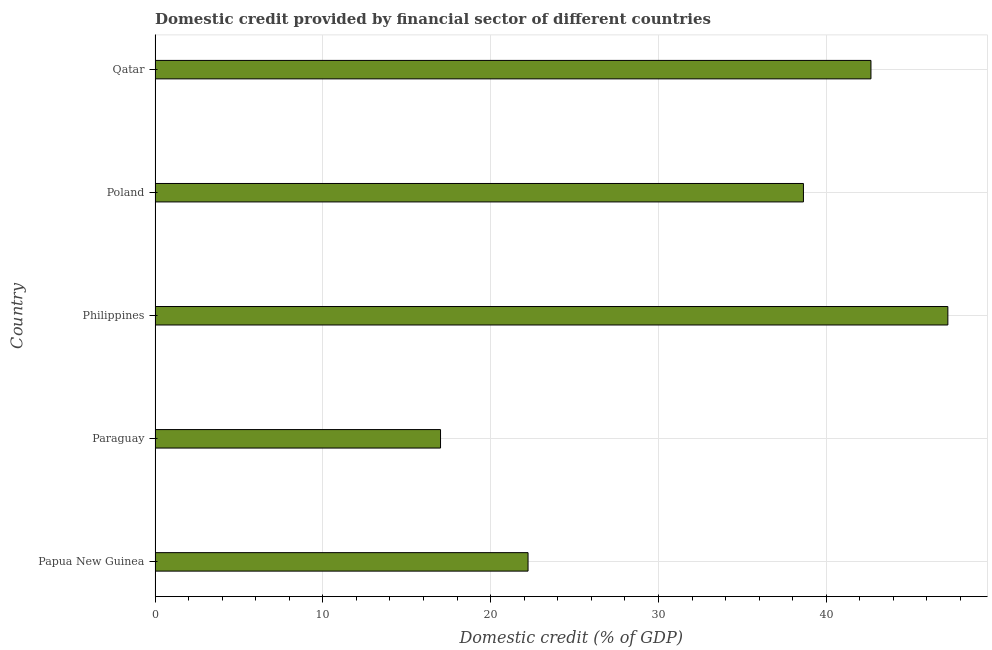What is the title of the graph?
Provide a short and direct response. Domestic credit provided by financial sector of different countries. What is the label or title of the X-axis?
Ensure brevity in your answer.  Domestic credit (% of GDP). What is the domestic credit provided by financial sector in Paraguay?
Provide a succinct answer. 17.01. Across all countries, what is the maximum domestic credit provided by financial sector?
Keep it short and to the point. 47.25. Across all countries, what is the minimum domestic credit provided by financial sector?
Your answer should be compact. 17.01. In which country was the domestic credit provided by financial sector minimum?
Ensure brevity in your answer.  Paraguay. What is the sum of the domestic credit provided by financial sector?
Ensure brevity in your answer.  167.79. What is the difference between the domestic credit provided by financial sector in Paraguay and Poland?
Give a very brief answer. -21.63. What is the average domestic credit provided by financial sector per country?
Your answer should be compact. 33.56. What is the median domestic credit provided by financial sector?
Make the answer very short. 38.64. What is the ratio of the domestic credit provided by financial sector in Philippines to that in Poland?
Make the answer very short. 1.22. Is the domestic credit provided by financial sector in Poland less than that in Qatar?
Your answer should be compact. Yes. What is the difference between the highest and the second highest domestic credit provided by financial sector?
Ensure brevity in your answer.  4.58. Is the sum of the domestic credit provided by financial sector in Papua New Guinea and Poland greater than the maximum domestic credit provided by financial sector across all countries?
Offer a terse response. Yes. What is the difference between the highest and the lowest domestic credit provided by financial sector?
Your answer should be compact. 30.23. In how many countries, is the domestic credit provided by financial sector greater than the average domestic credit provided by financial sector taken over all countries?
Your answer should be compact. 3. How many bars are there?
Offer a very short reply. 5. Are all the bars in the graph horizontal?
Ensure brevity in your answer.  Yes. How many countries are there in the graph?
Your response must be concise. 5. Are the values on the major ticks of X-axis written in scientific E-notation?
Provide a succinct answer. No. What is the Domestic credit (% of GDP) in Papua New Guinea?
Provide a short and direct response. 22.23. What is the Domestic credit (% of GDP) of Paraguay?
Make the answer very short. 17.01. What is the Domestic credit (% of GDP) in Philippines?
Offer a terse response. 47.25. What is the Domestic credit (% of GDP) in Poland?
Keep it short and to the point. 38.64. What is the Domestic credit (% of GDP) of Qatar?
Your answer should be compact. 42.66. What is the difference between the Domestic credit (% of GDP) in Papua New Guinea and Paraguay?
Make the answer very short. 5.22. What is the difference between the Domestic credit (% of GDP) in Papua New Guinea and Philippines?
Your answer should be compact. -25.02. What is the difference between the Domestic credit (% of GDP) in Papua New Guinea and Poland?
Make the answer very short. -16.41. What is the difference between the Domestic credit (% of GDP) in Papua New Guinea and Qatar?
Give a very brief answer. -20.44. What is the difference between the Domestic credit (% of GDP) in Paraguay and Philippines?
Offer a very short reply. -30.23. What is the difference between the Domestic credit (% of GDP) in Paraguay and Poland?
Your answer should be very brief. -21.63. What is the difference between the Domestic credit (% of GDP) in Paraguay and Qatar?
Your answer should be compact. -25.65. What is the difference between the Domestic credit (% of GDP) in Philippines and Poland?
Make the answer very short. 8.61. What is the difference between the Domestic credit (% of GDP) in Philippines and Qatar?
Ensure brevity in your answer.  4.58. What is the difference between the Domestic credit (% of GDP) in Poland and Qatar?
Make the answer very short. -4.02. What is the ratio of the Domestic credit (% of GDP) in Papua New Guinea to that in Paraguay?
Offer a very short reply. 1.31. What is the ratio of the Domestic credit (% of GDP) in Papua New Guinea to that in Philippines?
Provide a short and direct response. 0.47. What is the ratio of the Domestic credit (% of GDP) in Papua New Guinea to that in Poland?
Offer a terse response. 0.57. What is the ratio of the Domestic credit (% of GDP) in Papua New Guinea to that in Qatar?
Make the answer very short. 0.52. What is the ratio of the Domestic credit (% of GDP) in Paraguay to that in Philippines?
Provide a succinct answer. 0.36. What is the ratio of the Domestic credit (% of GDP) in Paraguay to that in Poland?
Your answer should be compact. 0.44. What is the ratio of the Domestic credit (% of GDP) in Paraguay to that in Qatar?
Keep it short and to the point. 0.4. What is the ratio of the Domestic credit (% of GDP) in Philippines to that in Poland?
Your answer should be compact. 1.22. What is the ratio of the Domestic credit (% of GDP) in Philippines to that in Qatar?
Your response must be concise. 1.11. What is the ratio of the Domestic credit (% of GDP) in Poland to that in Qatar?
Keep it short and to the point. 0.91. 